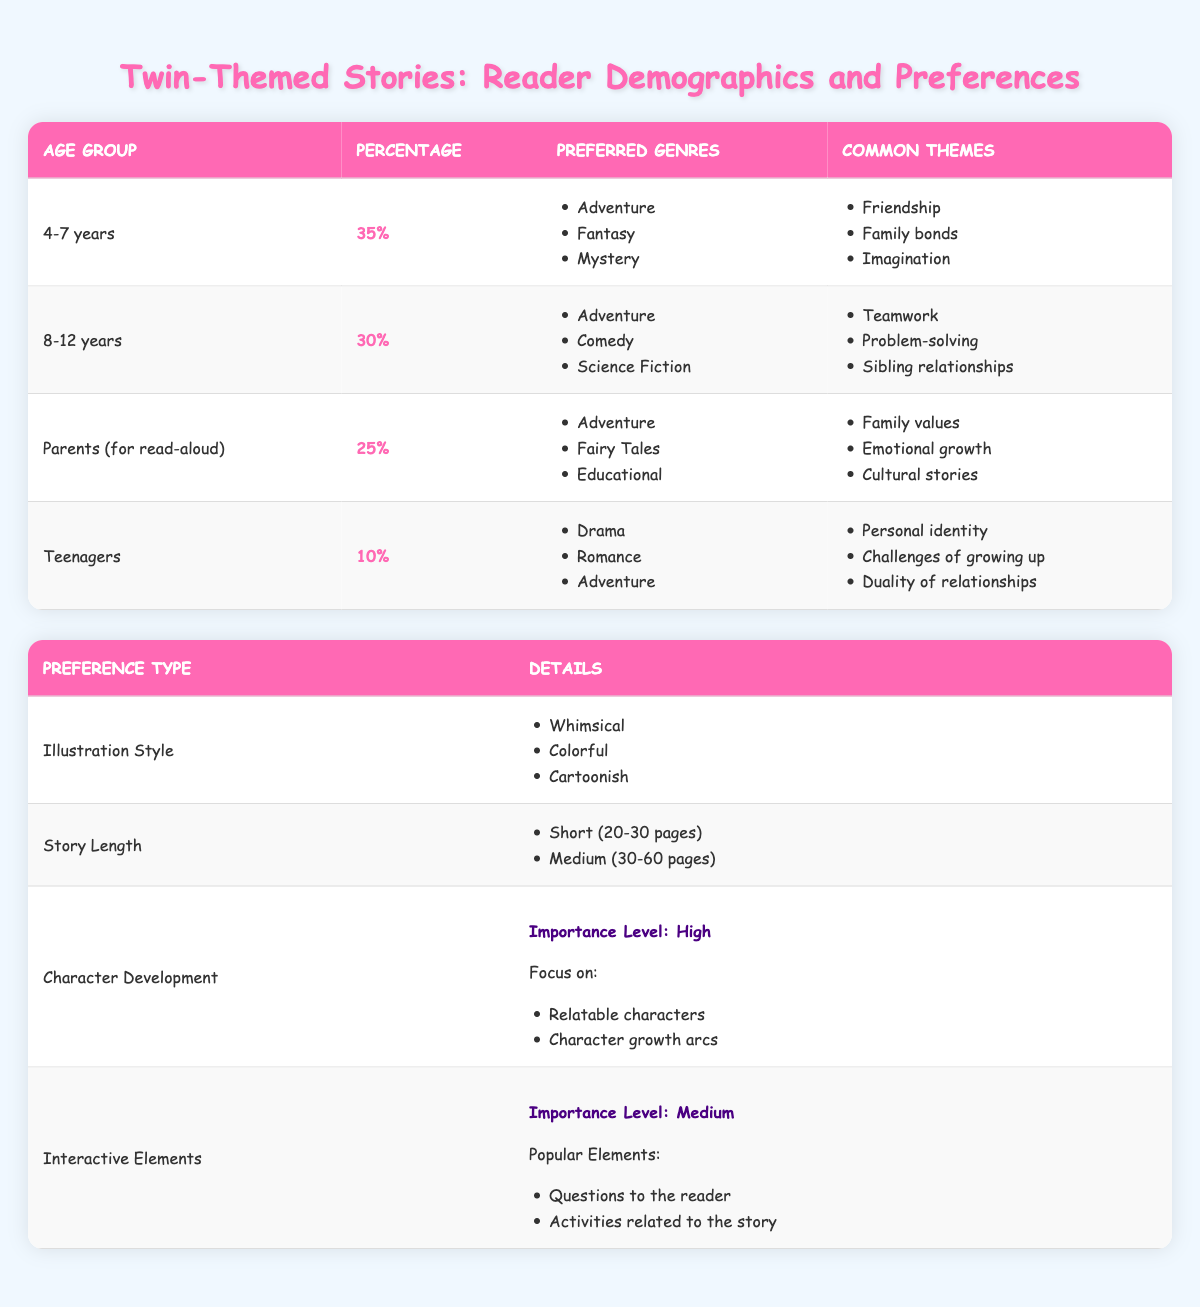What percentage of readers are between the ages of 4-7 years? The table shows that the age group of 4-7 years has a percentage of 35%.
Answer: 35% What are the preferred genres for the age group of 8-12 years? The table lists the preferred genres for the age group of 8-12 years as Adventure, Comedy, and Science Fiction.
Answer: Adventure, Comedy, Science Fiction Which age group has the highest percentage of readers? By comparing the percentages in the table, the age group 4-7 years (35%) has the highest percentage compared to 8-12 years (30%), Parents (25%), and Teenagers (10%).
Answer: 4-7 years What common themes are associated with parents reading twin-themed stories? The table indicates that the common themes for parents (reading aloud) include Family values, Emotional growth, and Cultural stories.
Answer: Family values, Emotional growth, Cultural stories Is the importance of character development high for readers of twin-themed stories? Based on the data, the table specifies that the importance level for character development is High.
Answer: Yes What is the total percentage of readers in the age group of 8-12 years and teenagers combined? To find the total percentage, we add the percentages of the two age groups: 30% (8-12 years) + 10% (Teenagers) = 40%.
Answer: 40% Are whimsical illustrations preferred more than cartoonish illustrations for twin-themed stories? The table lists Whimsical and Cartoonish as popular styles, but does not indicate a comparison between them, so we cannot definitively say if one is preferred more than the other.
Answer: No What interactive elements are considered popular within the reader preferences? The table shows that the popular interactive elements include Questions to the reader and Activities related to the story.
Answer: Questions to the reader, Activities related to the story What is the preferred length for twin-themed storybooks? From the table, the preferred length for storybooks is either Short (20-30 pages) or Medium (30-60 pages).
Answer: Short (20-30 pages), Medium (30-60 pages) 